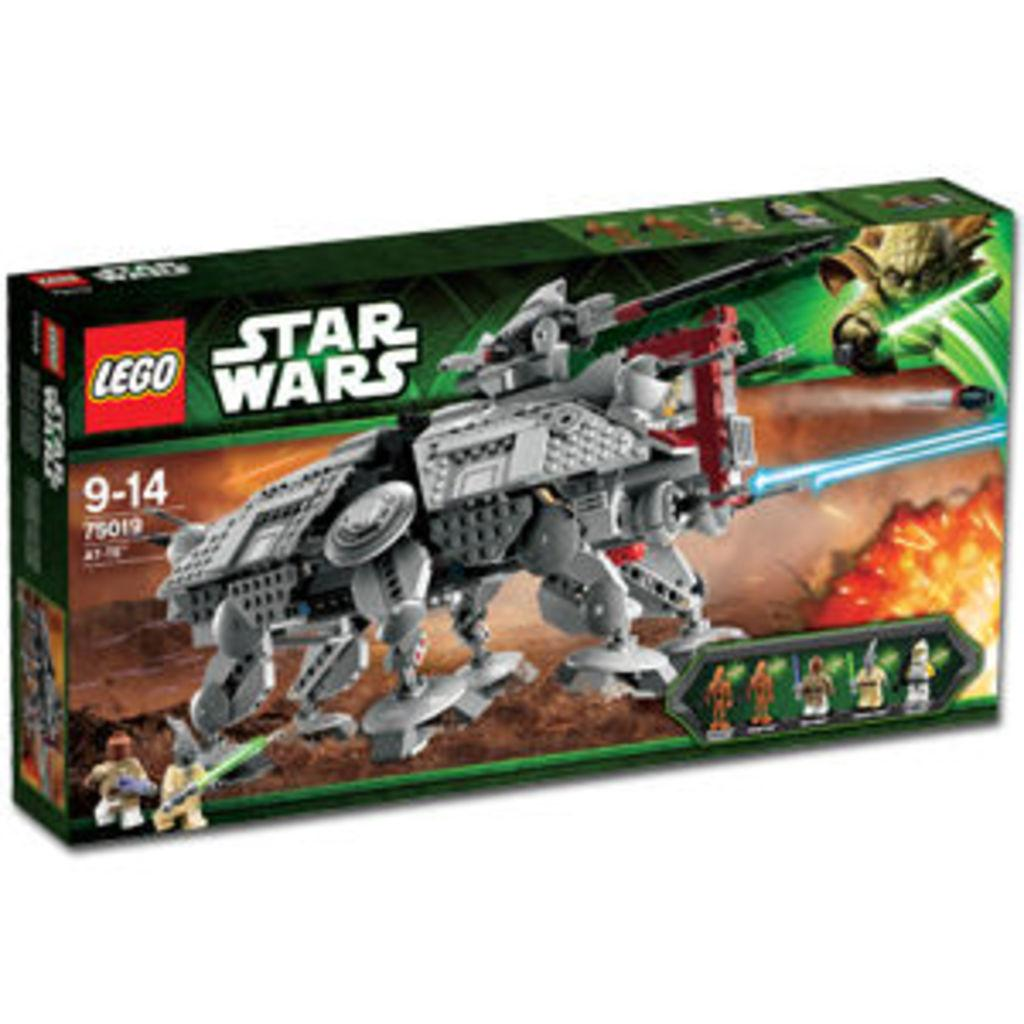What is the main object in the image? There is a box in the image. What is depicted on the box? There is a Lego toy on the box. What is written on the box? The box has "Star Wars" written on it. How many pigs are visible in the image? There are no pigs present in the image. Is there a birthday celebration happening in the image? There is no indication of a birthday celebration in the image. 